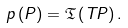Convert formula to latex. <formula><loc_0><loc_0><loc_500><loc_500>p \left ( P \right ) = \mathfrak { T } \left ( T P \right ) .</formula> 